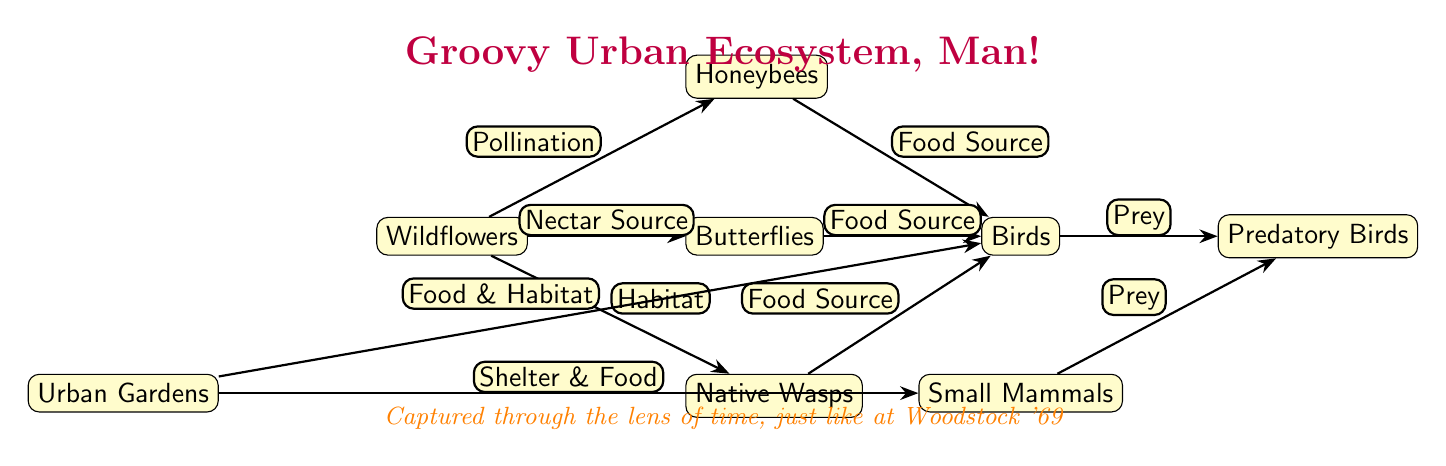What is the main source of nectar for butterflies in this food chain? The diagram indicates that wildflowers serve as the nectar source for butterflies, as shown by the edge labeled "Nectar Source" connecting wildflowers to butterflies.
Answer: Wildflowers How many edges are connected to the birds in the diagram? By examining the connections, birds have three edges connecting them to honeybees, butterflies, and native wasps as food sources, and one edge from urban gardens as a source of food and habitat, totaling four edges.
Answer: 4 Which organism is directly linked to pollination? According to the diagram, honeybees are directly linked to pollination through the edge labeled "Pollination" that connects wildflowers to honeybees.
Answer: Honeybees What type of relationship do urban gardens provide for small mammals? The diagram specifies that urban gardens provide both shelter and food for small mammals, which is shown by the edge labeled "Shelter & Food" connecting urban gardens to small mammals.
Answer: Shelter & Food If wildflowers were to disappear, which pollinator would be most affected, and why? The disappearance of wildflowers would affect honeybees because they rely on wildflowers for pollination, as indicated by the edge labeled "Pollination." This implies honeybees' existence depends on the availability of wildflowers.
Answer: Honeybees How many types of birds are shown in this food chain? The diagram displays only one type of bird, indicated simply as "Birds," with arrows indicating connections to other organisms such as butterflies, honeybees, and small mammals.
Answer: 1 What is the role of native wasps in this ecosystem? The diagram illustrates that native wasps provide habitat and serve as a food source for birds, as indicated by the edge connecting native wasps to birds labeled "Food Source."
Answer: Food Source Identify the apex predator represented in the diagram. The apex predator is represented by the node labeled "Predatory Birds," which is connected twice as prey by both birds and small mammals, illustrating its position at the top of this food chain.
Answer: Predatory Birds 